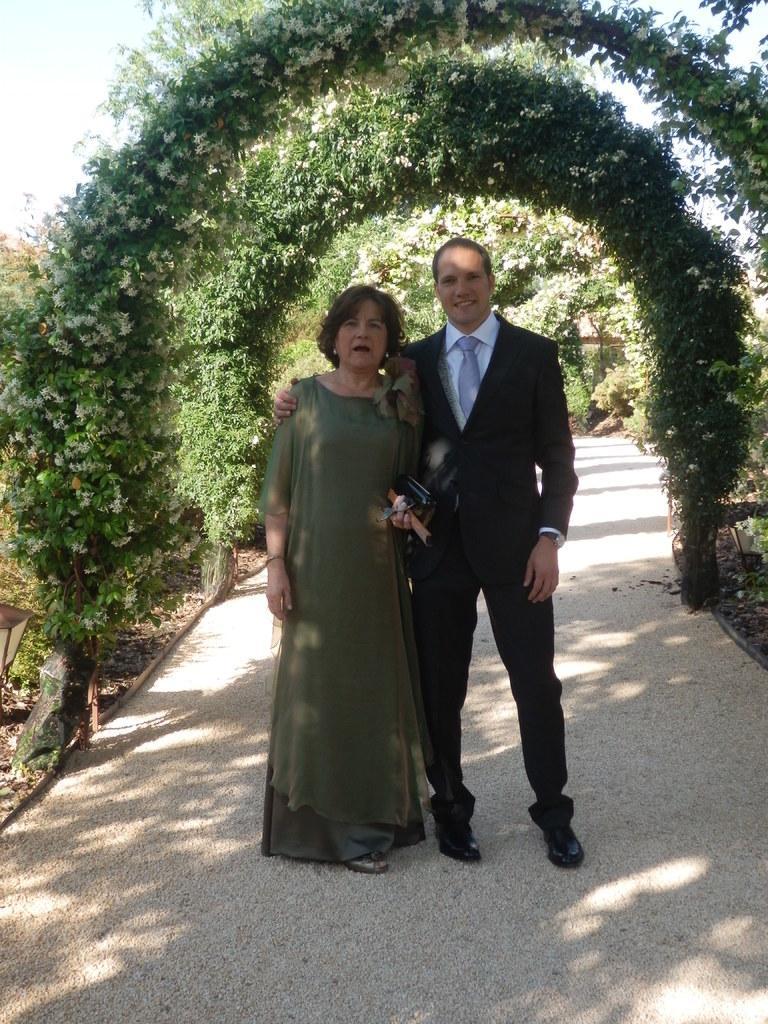Can you describe this image briefly? In this image we can see a man and a woman standing on the path. In the background we can see the green leaf arches. We can also see the sky. 